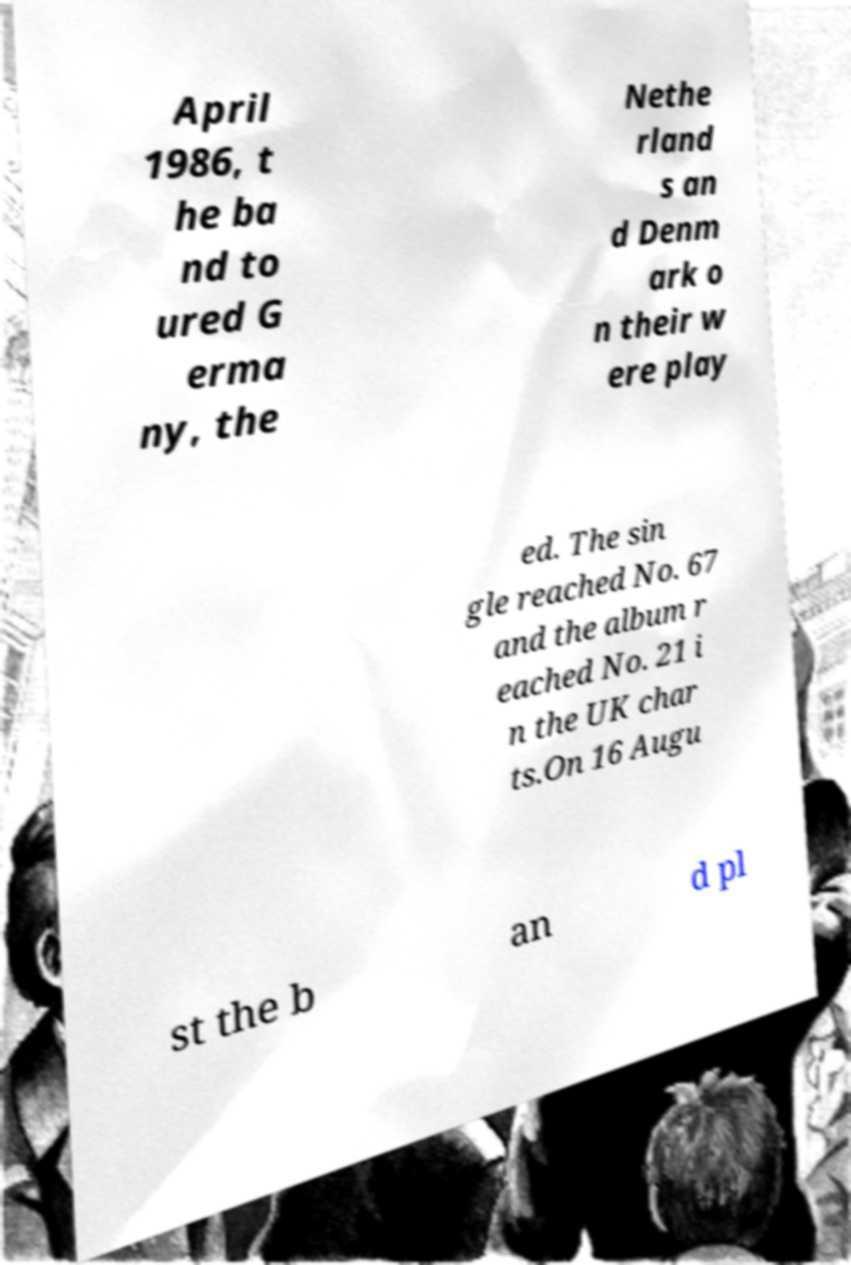Please read and relay the text visible in this image. What does it say? April 1986, t he ba nd to ured G erma ny, the Nethe rland s an d Denm ark o n their w ere play ed. The sin gle reached No. 67 and the album r eached No. 21 i n the UK char ts.On 16 Augu st the b an d pl 